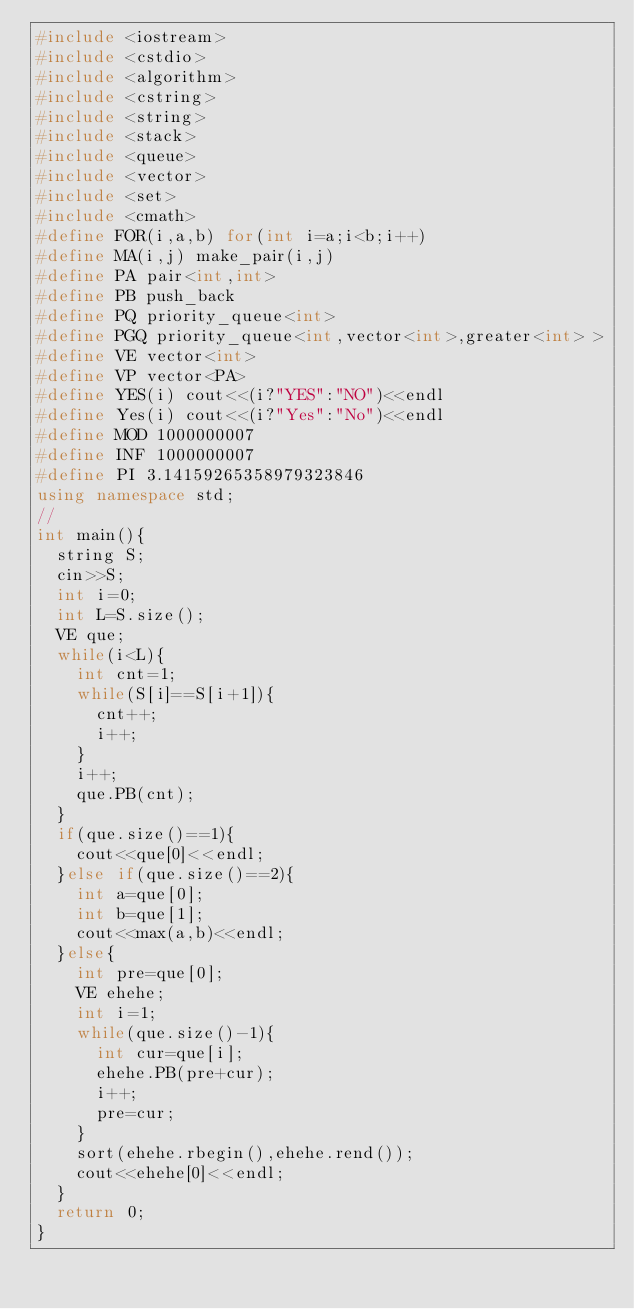<code> <loc_0><loc_0><loc_500><loc_500><_C++_>#include <iostream>
#include <cstdio>
#include <algorithm>
#include <cstring>
#include <string>
#include <stack>
#include <queue>
#include <vector>
#include <set>
#include <cmath>
#define FOR(i,a,b) for(int i=a;i<b;i++)
#define MA(i,j) make_pair(i,j)
#define PA pair<int,int>
#define PB push_back
#define PQ priority_queue<int>
#define PGQ priority_queue<int,vector<int>,greater<int> >
#define VE vector<int>
#define VP vector<PA>
#define YES(i) cout<<(i?"YES":"NO")<<endl
#define Yes(i) cout<<(i?"Yes":"No")<<endl
#define MOD 1000000007
#define INF 1000000007
#define PI 3.14159265358979323846
using namespace std;
//
int main(){
  string S;
  cin>>S;
  int i=0;
  int L=S.size();
  VE que;
  while(i<L){
    int cnt=1;
    while(S[i]==S[i+1]){
      cnt++;
      i++;
    }
    i++;
    que.PB(cnt);
  }
  if(que.size()==1){
    cout<<que[0]<<endl;
  }else if(que.size()==2){
    int a=que[0];
    int b=que[1];
    cout<<max(a,b)<<endl;
  }else{
    int pre=que[0];
    VE ehehe;
    int i=1;
    while(que.size()-1){
      int cur=que[i];
      ehehe.PB(pre+cur);
      i++;
      pre=cur;
    }
    sort(ehehe.rbegin(),ehehe.rend());
    cout<<ehehe[0]<<endl;
  }
  return 0;
}
</code> 